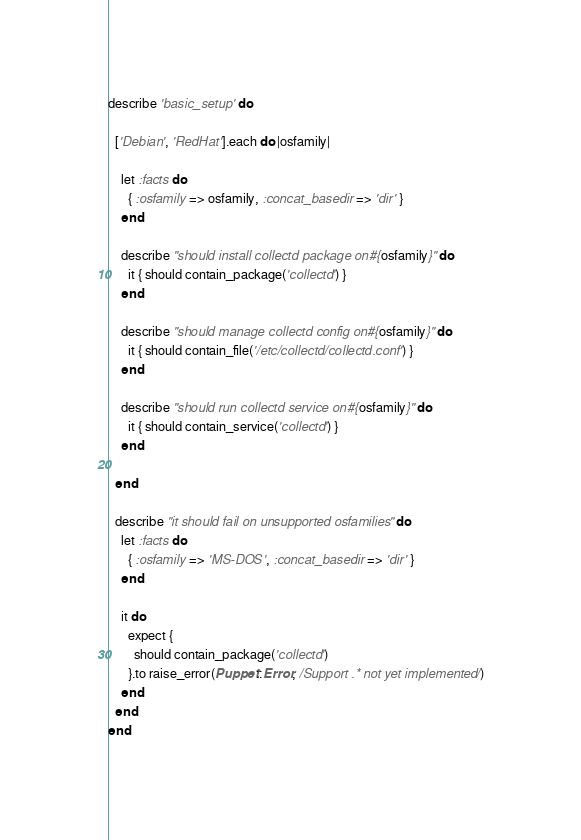Convert code to text. <code><loc_0><loc_0><loc_500><loc_500><_Ruby_>describe 'basic_setup' do

  ['Debian', 'RedHat'].each do |osfamily|

    let :facts do
      { :osfamily => osfamily, :concat_basedir => 'dir' }
    end

    describe "should install collectd package on #{osfamily}" do
      it { should contain_package('collectd') }
    end

    describe "should manage collectd config on #{osfamily}" do
      it { should contain_file('/etc/collectd/collectd.conf') }
    end

    describe "should run collectd service on #{osfamily}" do
      it { should contain_service('collectd') }
    end

  end

  describe "it should fail on unsupported osfamilies" do
    let :facts do
      { :osfamily => 'MS-DOS', :concat_basedir => 'dir' }
    end

    it do
      expect {
        should contain_package('collectd')
      }.to raise_error(Puppet::Error, /Support .* not yet implemented/)
    end
  end
end
</code> 